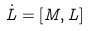Convert formula to latex. <formula><loc_0><loc_0><loc_500><loc_500>\dot { L } = [ M , L ]</formula> 